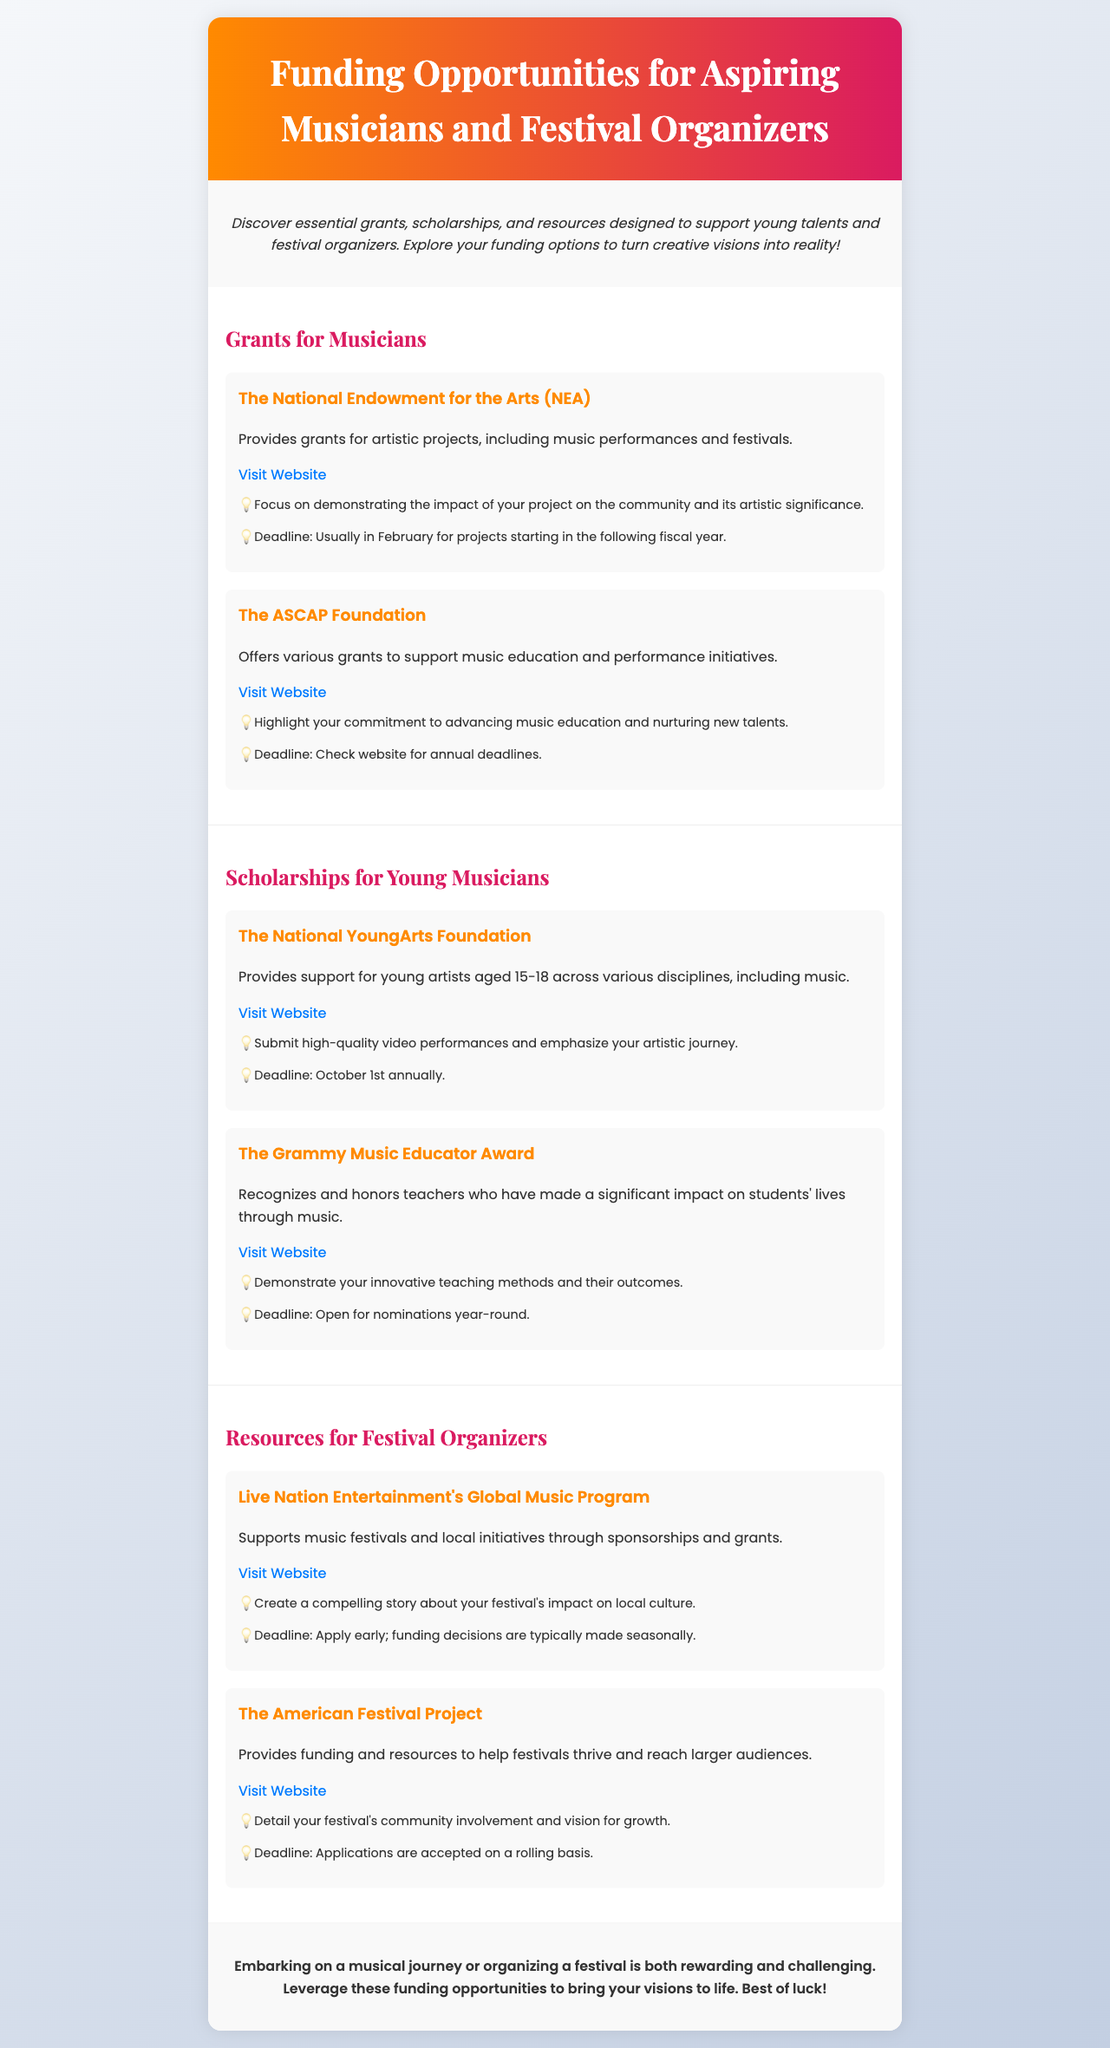What type of funding does the National Endowment for the Arts provide? The National Endowment for the Arts provides grants for artistic projects, including music performances and festivals.
Answer: Grants What is the deadline for The National YoungArts Foundation scholarship? The deadline for The National YoungArts Foundation scholarship is stated clearly in the document.
Answer: October 1st annually What should you focus on when applying to The ASCAP Foundation? The document specifies what applicants should highlight when applying.
Answer: Commitment to advancing music education What type of support does Live Nation Entertainment's Global Music Program offer? The document outlines the type of support provided by Live Nation Entertainment's Global Music Program.
Answer: Sponsorships and grants How often does The American Festival Project accept applications? The document mentions the frequency of application acceptance.
Answer: Rolling basis What is a suggested tip for applying to the Grammy Music Educator Award? Tips for applicants are included in the document.
Answer: Demonstrate innovative teaching methods What age range does The National YoungArts Foundation support? The age range for applicants to The National YoungArts Foundation is indicated in the document.
Answer: 15-18 years old 